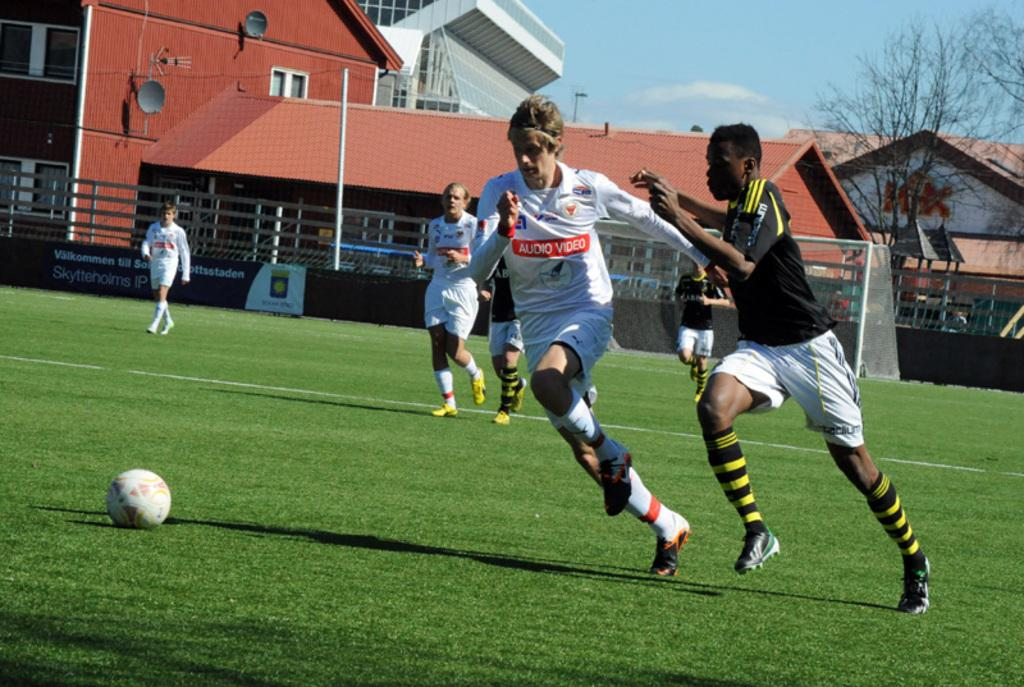<image>
Offer a succinct explanation of the picture presented. a soccer player that has the word video on his shirt 